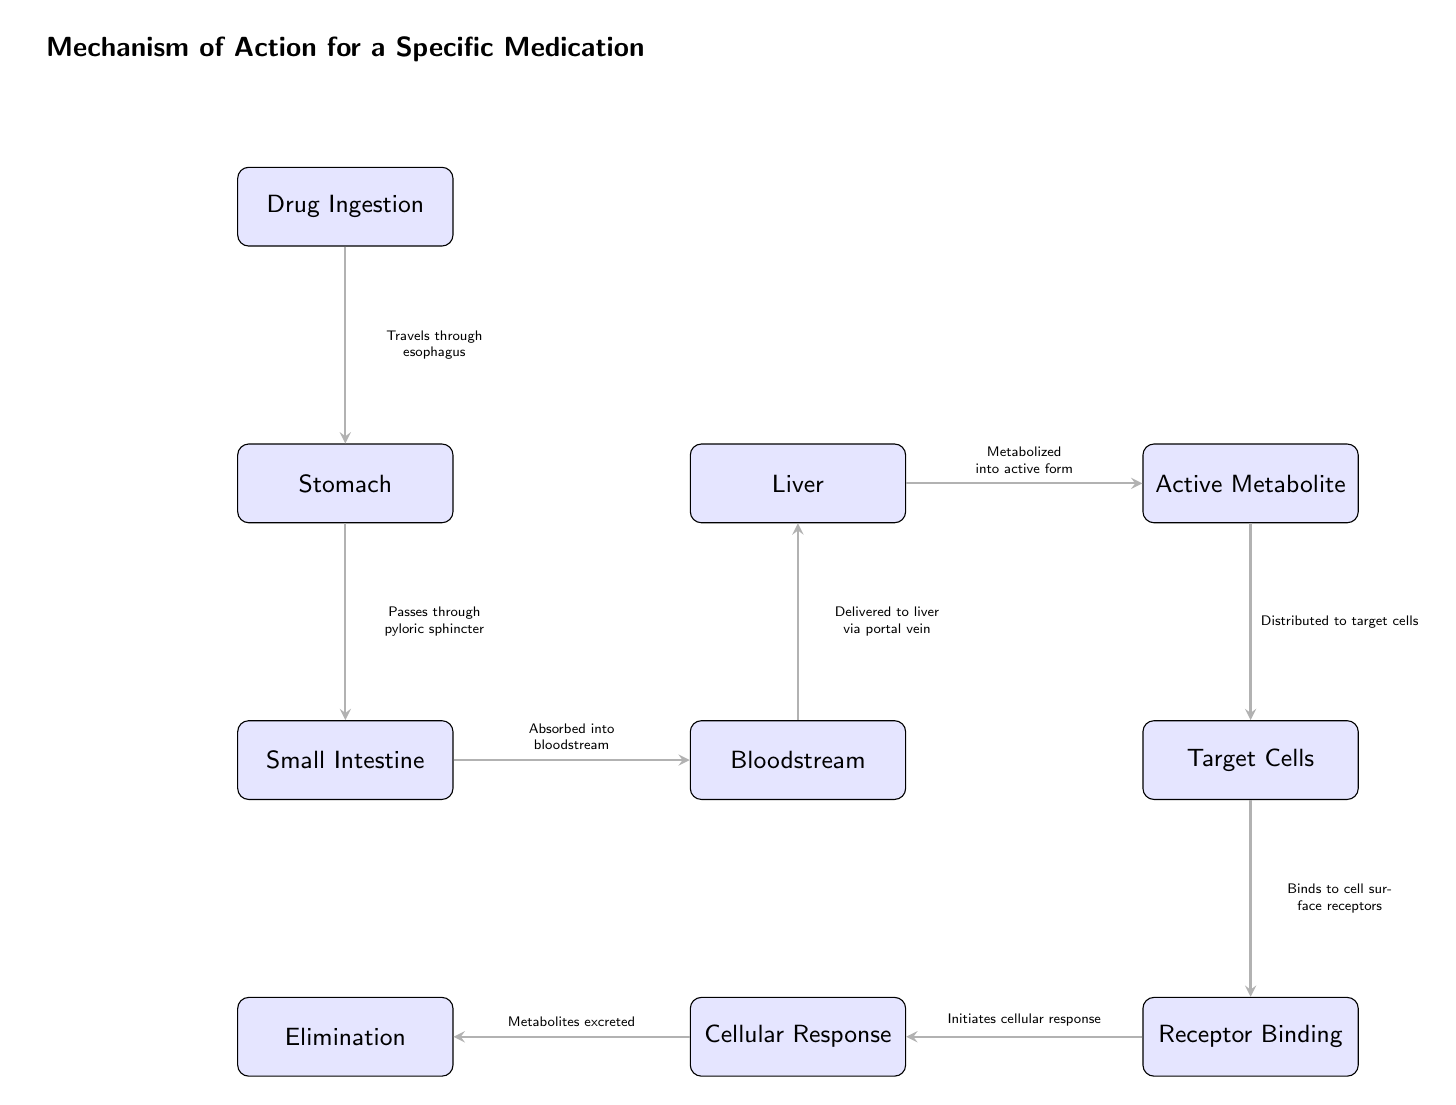What is the first step in the drug's journey? The diagram starts with "Drug Ingestion" at the top, indicating that this is the initial step in the process.
Answer: Drug Ingestion What happens after the drug passes through the stomach? According to the diagram, after passing through the stomach, the drug moves to the "Small Intestine." This is indicated by the direct connection drawn from the stomach to the small intestine.
Answer: Small Intestine How many nodes are present in the diagram? By counting the nodes in the diagram, we find there are a total of 10 nodes representing various stages of the drug's journey.
Answer: 10 What process occurs in the liver? The diagram indicates that in the liver, the drug is "Metabolized into active form," which refers to its transformation into a usable biologically active metabolite.
Answer: Metabolized into active form What binds to the cell surface receptors? In the flow of the diagram, the "Active Metabolite" is the element that "Binds to cell surface receptors," indicating its role in initiating a biological effect at the target cells.
Answer: Active Metabolite What is the final outcome depicted in the diagram? The last stage of the process as shown in the diagram is "Metabolites excreted," indicating the final outcome after the cellular response has initiated.
Answer: Metabolites excreted What flows from the Small Intestine to the Bloodstream? The diagram shows that after absorption, the drug "Absorbed into bloodstream" flows from the Small Intestine to the Bloodstream, indicating the mechanism of absorption.
Answer: Absorbed into bloodstream In which part of the diagram does elimination occur? The "Elimination" node occurs at the far left in the diagram, following the "Cellular Response" as the final step in the process.
Answer: Elimination What is the pathway from the bloodstream to the target cells? The pathway is indicated by the direct arrow moving from "Bloodstream" to "Target Cells," showing how the drug travels to its action site.
Answer: Target Cells 